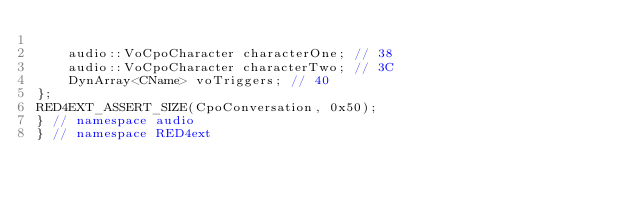<code> <loc_0><loc_0><loc_500><loc_500><_C++_>
    audio::VoCpoCharacter characterOne; // 38
    audio::VoCpoCharacter characterTwo; // 3C
    DynArray<CName> voTriggers; // 40
};
RED4EXT_ASSERT_SIZE(CpoConversation, 0x50);
} // namespace audio
} // namespace RED4ext
</code> 